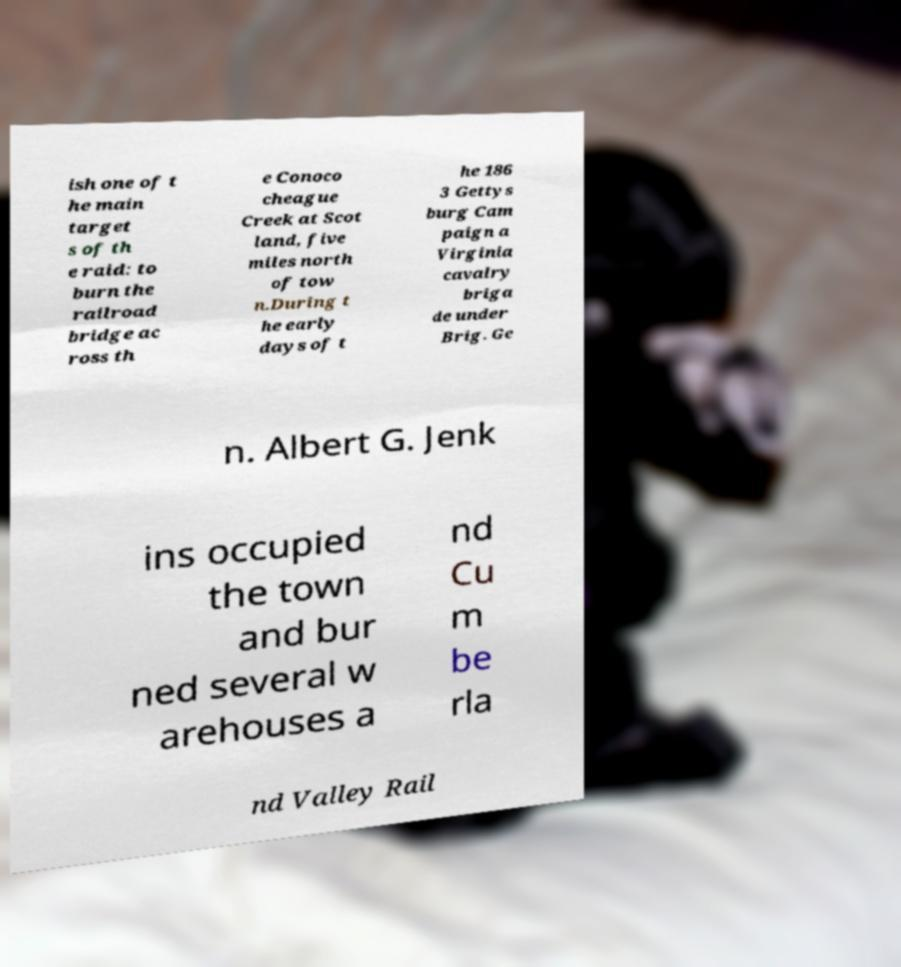Please identify and transcribe the text found in this image. ish one of t he main target s of th e raid: to burn the railroad bridge ac ross th e Conoco cheague Creek at Scot land, five miles north of tow n.During t he early days of t he 186 3 Gettys burg Cam paign a Virginia cavalry briga de under Brig. Ge n. Albert G. Jenk ins occupied the town and bur ned several w arehouses a nd Cu m be rla nd Valley Rail 